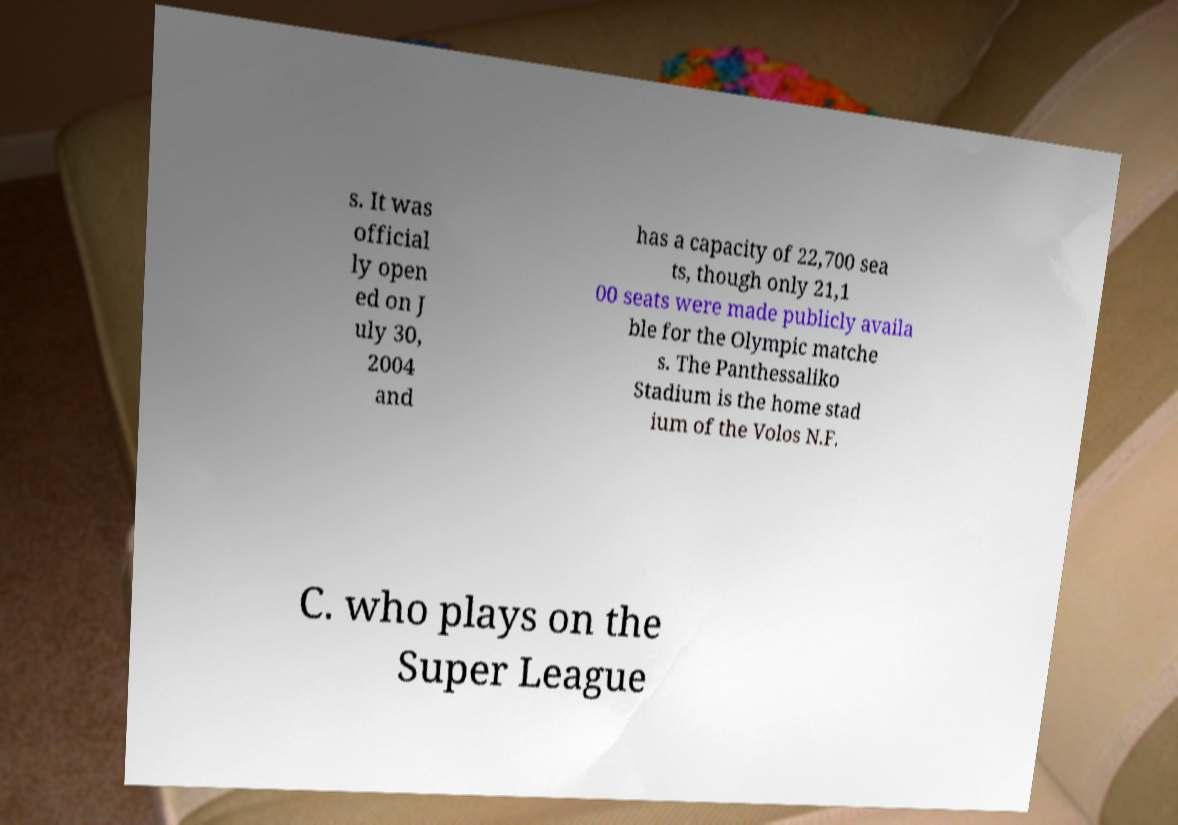Can you accurately transcribe the text from the provided image for me? s. It was official ly open ed on J uly 30, 2004 and has a capacity of 22,700 sea ts, though only 21,1 00 seats were made publicly availa ble for the Olympic matche s. The Panthessaliko Stadium is the home stad ium of the Volos N.F. C. who plays on the Super League 